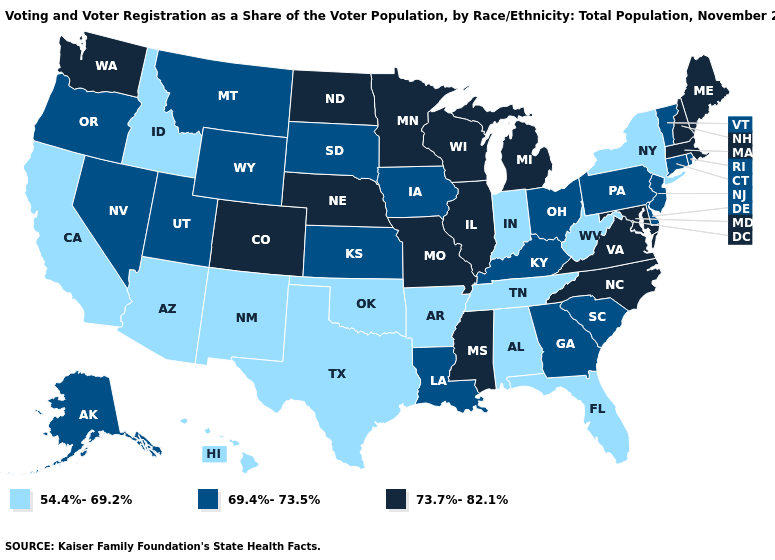Does New Mexico have the highest value in the West?
Write a very short answer. No. What is the value of Utah?
Keep it brief. 69.4%-73.5%. Name the states that have a value in the range 73.7%-82.1%?
Short answer required. Colorado, Illinois, Maine, Maryland, Massachusetts, Michigan, Minnesota, Mississippi, Missouri, Nebraska, New Hampshire, North Carolina, North Dakota, Virginia, Washington, Wisconsin. Name the states that have a value in the range 54.4%-69.2%?
Give a very brief answer. Alabama, Arizona, Arkansas, California, Florida, Hawaii, Idaho, Indiana, New Mexico, New York, Oklahoma, Tennessee, Texas, West Virginia. Is the legend a continuous bar?
Quick response, please. No. Among the states that border Utah , does New Mexico have the lowest value?
Concise answer only. Yes. Does Texas have the same value as Maine?
Answer briefly. No. Does Arkansas have a lower value than New Mexico?
Short answer required. No. What is the value of Florida?
Concise answer only. 54.4%-69.2%. What is the highest value in the MidWest ?
Concise answer only. 73.7%-82.1%. What is the value of Nevada?
Concise answer only. 69.4%-73.5%. Which states hav the highest value in the Northeast?
Keep it brief. Maine, Massachusetts, New Hampshire. What is the value of New Hampshire?
Keep it brief. 73.7%-82.1%. Name the states that have a value in the range 54.4%-69.2%?
Write a very short answer. Alabama, Arizona, Arkansas, California, Florida, Hawaii, Idaho, Indiana, New Mexico, New York, Oklahoma, Tennessee, Texas, West Virginia. 